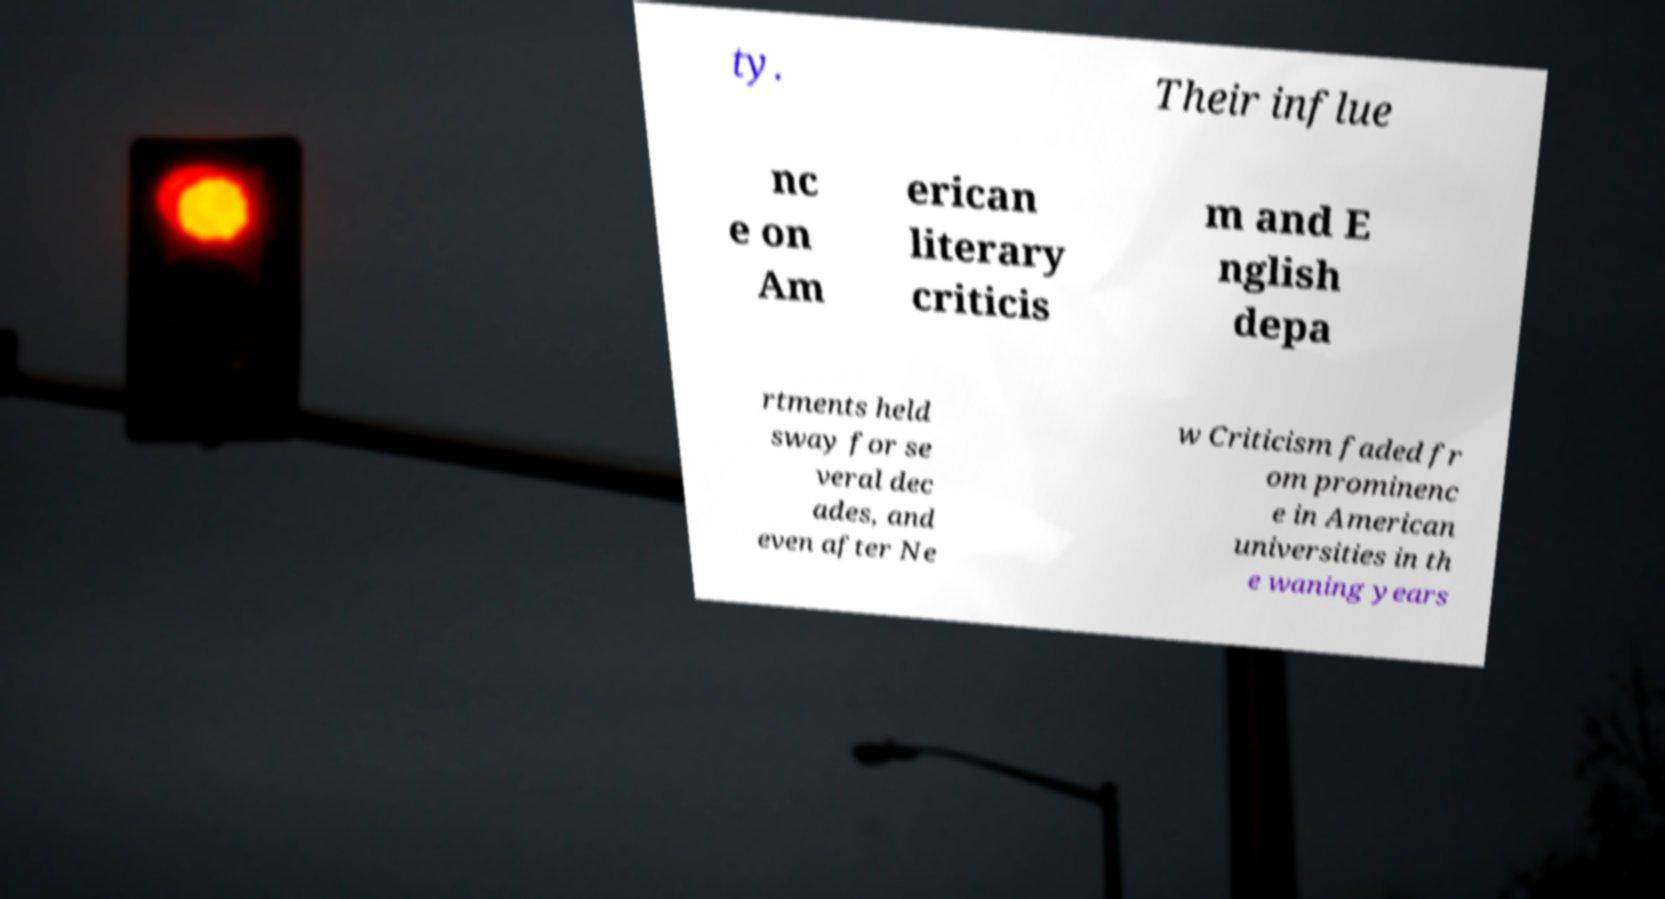Please identify and transcribe the text found in this image. ty. Their influe nc e on Am erican literary criticis m and E nglish depa rtments held sway for se veral dec ades, and even after Ne w Criticism faded fr om prominenc e in American universities in th e waning years 